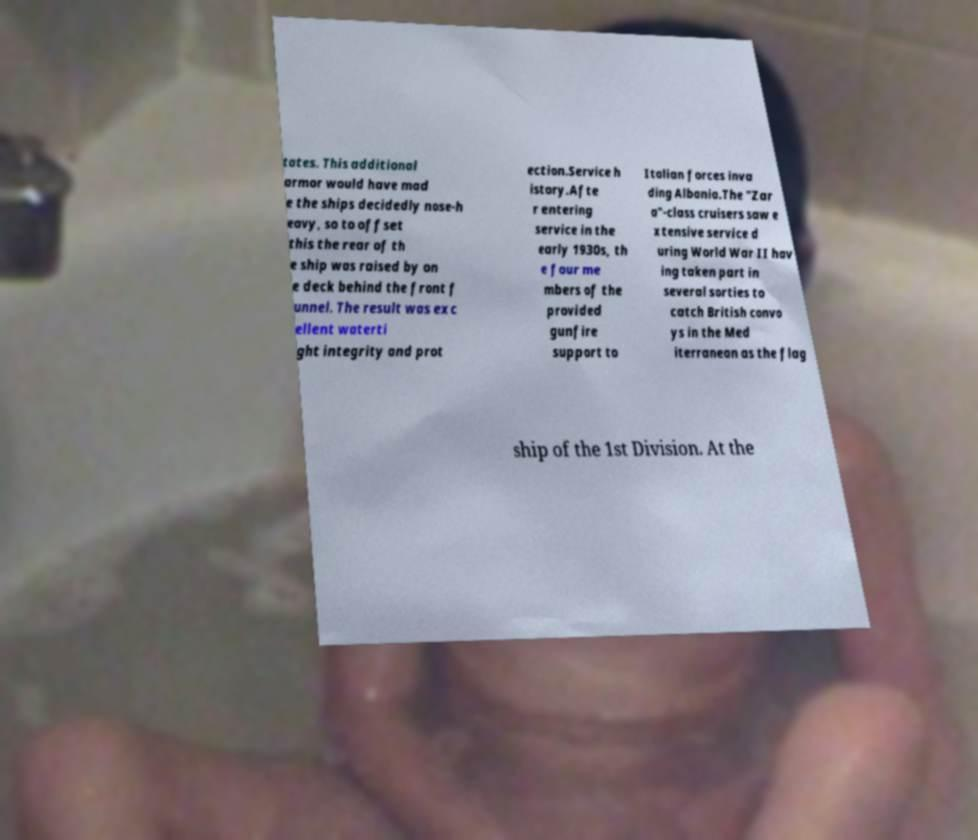I need the written content from this picture converted into text. Can you do that? tates. This additional armor would have mad e the ships decidedly nose-h eavy, so to offset this the rear of th e ship was raised by on e deck behind the front f unnel. The result was exc ellent waterti ght integrity and prot ection.Service h istory.Afte r entering service in the early 1930s, th e four me mbers of the provided gunfire support to Italian forces inva ding Albania.The "Zar a"-class cruisers saw e xtensive service d uring World War II hav ing taken part in several sorties to catch British convo ys in the Med iterranean as the flag ship of the 1st Division. At the 